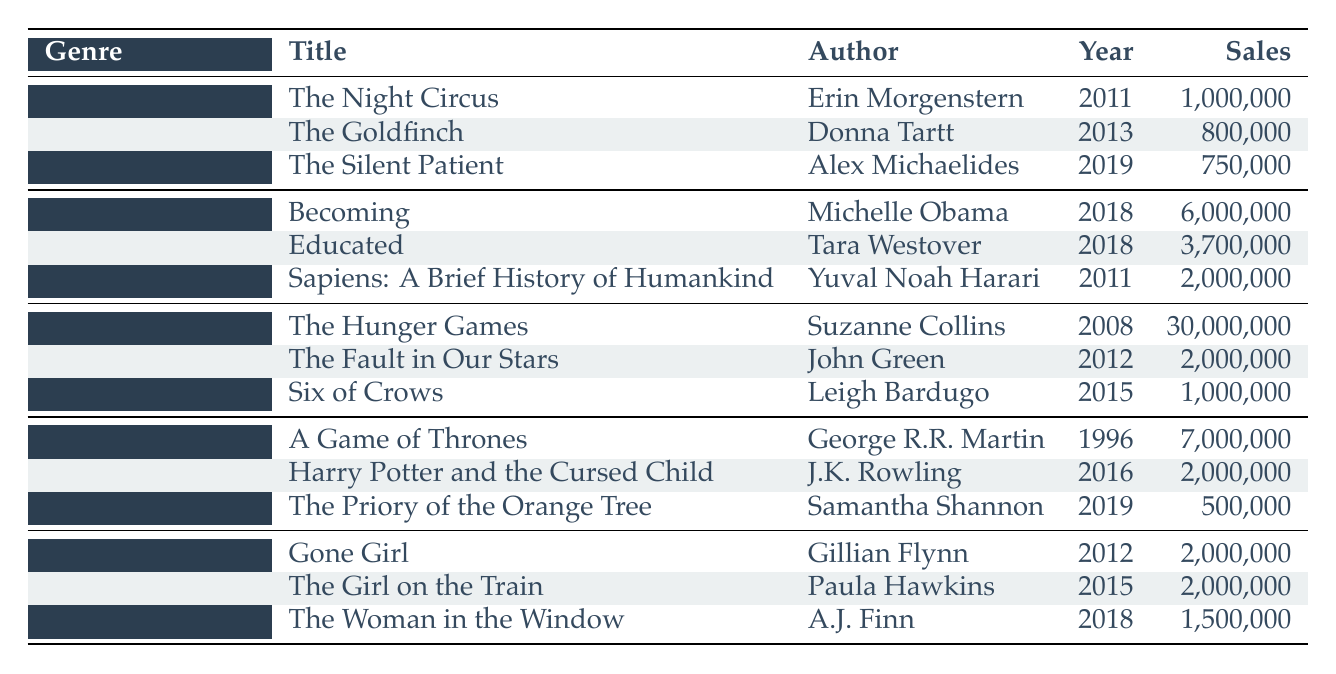What is the title of the bestselling fiction book released in 2019? The table shows that "The Silent Patient" by Alex Michaelides was released in 2019 and is listed under the Fiction genre.
Answer: The Silent Patient Which genre had the highest total sales across all its listed bestsellers? To find which genre has the highest total sales, add the sales for each bestseller within each genre. Fiction: 1,000,000 + 800,000 + 750,000 = 2,550,000. Non-Fiction: 6,000,000 + 3,700,000 + 2,000,000 = 11,700,000. Young Adult: 30,000,000 + 2,000,000 + 1,000,000 = 33,000,000. Fantasy: 7,000,000 + 2,000,000 + 500,000 = 9,500,000. Mystery/Thriller: 2,000,000 + 2,000,000 + 1,500,000 = 5,500,000. The Young Adult genre has the highest total sales at 33,000,000.
Answer: Young Adult Is "The Girl on the Train" classified under the Fantasy genre? The table shows that "The Girl on the Train" by Paula Hawkins is listed under the Mystery/Thriller genre, not Fantasy.
Answer: No What are the total sales of the bestsellers in the Non-Fiction genre? The bestsellers in the Non-Fiction genre are "Becoming" (6,000,000), "Educated" (3,700,000), and "Sapiens: A Brief History of Humankind" (2,000,000). Adding these values gives a total of 6,000,000 + 3,700,000 + 2,000,000 = 11,700,000.
Answer: 11,700,000 How many bestsellers are listed for the Mystery/Thriller genre? The table indicates there are three bestsellers listed under the Mystery/Thriller genre: "Gone Girl," "The Girl on the Train," and "The Woman in the Window."
Answer: 3 Which author has the highest-selling book in the Young Adult genre? The Young Adult bestselling list contains "The Hunger Games" by Suzanne Collins with 30,000,000 sales, "The Fault in Our Stars" by John Green with 2,000,000, and "Six of Crows" by Leigh Bardugo with 1,000,000. Comparing the sales figures, "The Hunger Games" has the highest sales.
Answer: Suzanne Collins What is the average sales figure for the Fiction genre bestsellers? For the Fiction genre, the sales figures are 1,000,000, 800,000, and 750,000. Adding these gives 1,000,000 + 800,000 + 750,000 = 2,550,000. There are three books, so the average sales are 2,550,000 / 3 = 850,000.
Answer: 850,000 Did any book published before 2010 make it to the bestseller list in the last decade? "A Game of Thrones" by George R.R. Martin was published in 1996 and is included in the Fantasy genre. Therefore, a book published before 2010 did make it to the bestseller list.
Answer: Yes 